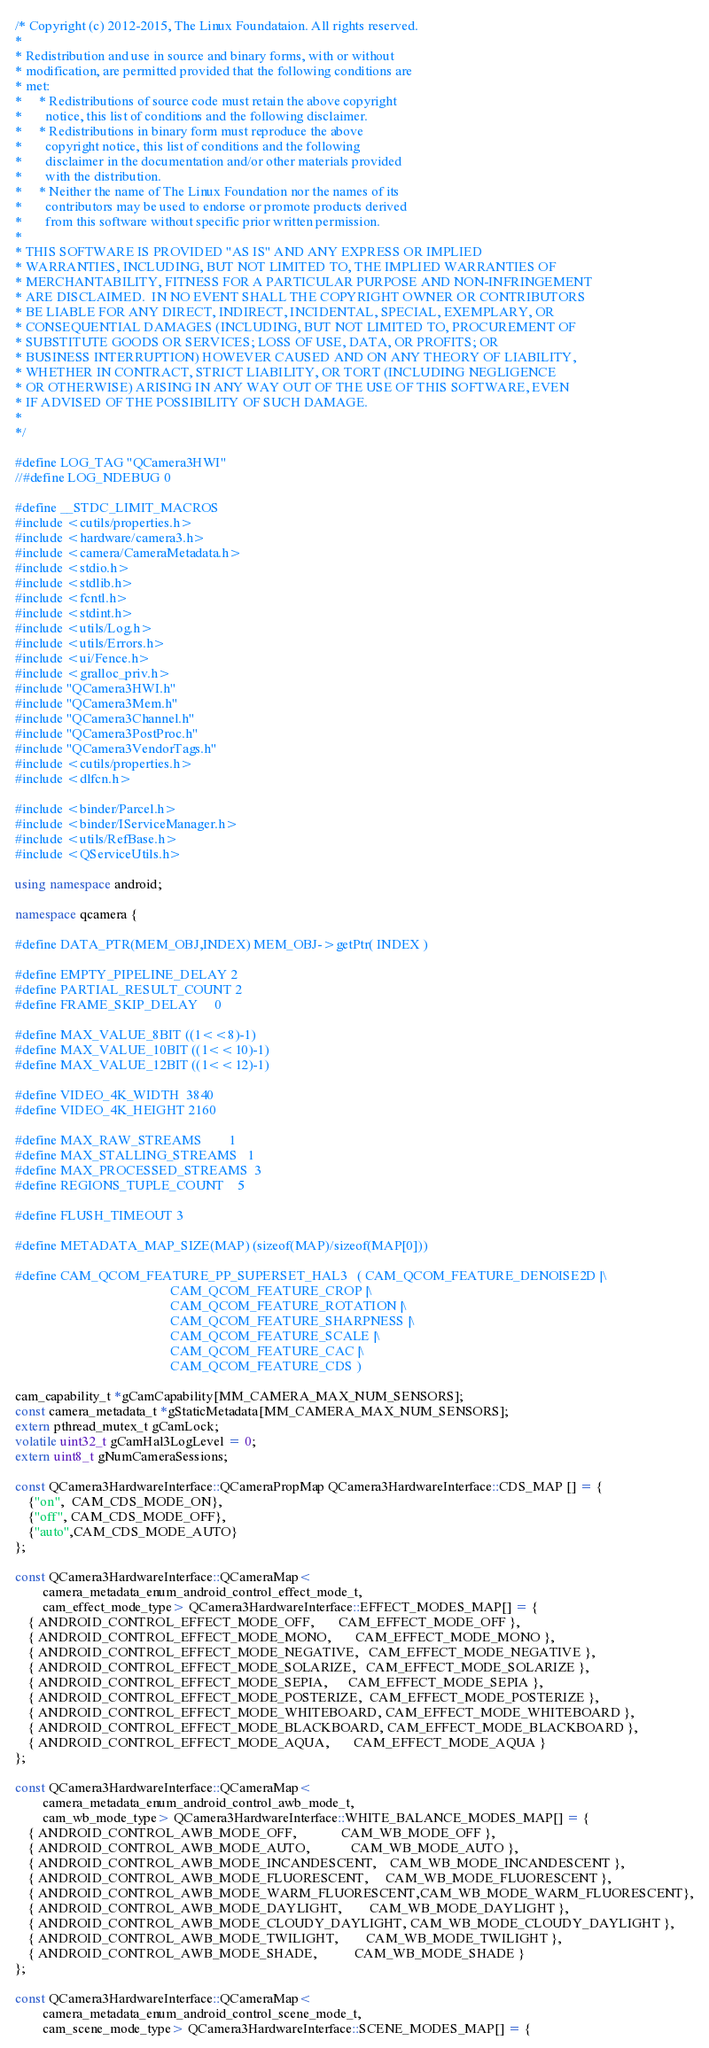Convert code to text. <code><loc_0><loc_0><loc_500><loc_500><_C++_>/* Copyright (c) 2012-2015, The Linux Foundataion. All rights reserved.
*
* Redistribution and use in source and binary forms, with or without
* modification, are permitted provided that the following conditions are
* met:
*     * Redistributions of source code must retain the above copyright
*       notice, this list of conditions and the following disclaimer.
*     * Redistributions in binary form must reproduce the above
*       copyright notice, this list of conditions and the following
*       disclaimer in the documentation and/or other materials provided
*       with the distribution.
*     * Neither the name of The Linux Foundation nor the names of its
*       contributors may be used to endorse or promote products derived
*       from this software without specific prior written permission.
*
* THIS SOFTWARE IS PROVIDED "AS IS" AND ANY EXPRESS OR IMPLIED
* WARRANTIES, INCLUDING, BUT NOT LIMITED TO, THE IMPLIED WARRANTIES OF
* MERCHANTABILITY, FITNESS FOR A PARTICULAR PURPOSE AND NON-INFRINGEMENT
* ARE DISCLAIMED.  IN NO EVENT SHALL THE COPYRIGHT OWNER OR CONTRIBUTORS
* BE LIABLE FOR ANY DIRECT, INDIRECT, INCIDENTAL, SPECIAL, EXEMPLARY, OR
* CONSEQUENTIAL DAMAGES (INCLUDING, BUT NOT LIMITED TO, PROCUREMENT OF
* SUBSTITUTE GOODS OR SERVICES; LOSS OF USE, DATA, OR PROFITS; OR
* BUSINESS INTERRUPTION) HOWEVER CAUSED AND ON ANY THEORY OF LIABILITY,
* WHETHER IN CONTRACT, STRICT LIABILITY, OR TORT (INCLUDING NEGLIGENCE
* OR OTHERWISE) ARISING IN ANY WAY OUT OF THE USE OF THIS SOFTWARE, EVEN
* IF ADVISED OF THE POSSIBILITY OF SUCH DAMAGE.
*
*/

#define LOG_TAG "QCamera3HWI"
//#define LOG_NDEBUG 0

#define __STDC_LIMIT_MACROS
#include <cutils/properties.h>
#include <hardware/camera3.h>
#include <camera/CameraMetadata.h>
#include <stdio.h>
#include <stdlib.h>
#include <fcntl.h>
#include <stdint.h>
#include <utils/Log.h>
#include <utils/Errors.h>
#include <ui/Fence.h>
#include <gralloc_priv.h>
#include "QCamera3HWI.h"
#include "QCamera3Mem.h"
#include "QCamera3Channel.h"
#include "QCamera3PostProc.h"
#include "QCamera3VendorTags.h"
#include <cutils/properties.h>
#include <dlfcn.h>

#include <binder/Parcel.h>
#include <binder/IServiceManager.h>
#include <utils/RefBase.h>
#include <QServiceUtils.h>

using namespace android;

namespace qcamera {

#define DATA_PTR(MEM_OBJ,INDEX) MEM_OBJ->getPtr( INDEX )

#define EMPTY_PIPELINE_DELAY 2
#define PARTIAL_RESULT_COUNT 2
#define FRAME_SKIP_DELAY     0

#define MAX_VALUE_8BIT ((1<<8)-1)
#define MAX_VALUE_10BIT ((1<<10)-1)
#define MAX_VALUE_12BIT ((1<<12)-1)

#define VIDEO_4K_WIDTH  3840
#define VIDEO_4K_HEIGHT 2160

#define MAX_RAW_STREAMS        1
#define MAX_STALLING_STREAMS   1
#define MAX_PROCESSED_STREAMS  3
#define REGIONS_TUPLE_COUNT    5

#define FLUSH_TIMEOUT 3

#define METADATA_MAP_SIZE(MAP) (sizeof(MAP)/sizeof(MAP[0]))

#define CAM_QCOM_FEATURE_PP_SUPERSET_HAL3   ( CAM_QCOM_FEATURE_DENOISE2D |\
                                              CAM_QCOM_FEATURE_CROP |\
                                              CAM_QCOM_FEATURE_ROTATION |\
                                              CAM_QCOM_FEATURE_SHARPNESS |\
                                              CAM_QCOM_FEATURE_SCALE |\
                                              CAM_QCOM_FEATURE_CAC |\
                                              CAM_QCOM_FEATURE_CDS )

cam_capability_t *gCamCapability[MM_CAMERA_MAX_NUM_SENSORS];
const camera_metadata_t *gStaticMetadata[MM_CAMERA_MAX_NUM_SENSORS];
extern pthread_mutex_t gCamLock;
volatile uint32_t gCamHal3LogLevel = 0;
extern uint8_t gNumCameraSessions;

const QCamera3HardwareInterface::QCameraPropMap QCamera3HardwareInterface::CDS_MAP [] = {
    {"on",  CAM_CDS_MODE_ON},
    {"off", CAM_CDS_MODE_OFF},
    {"auto",CAM_CDS_MODE_AUTO}
};

const QCamera3HardwareInterface::QCameraMap<
        camera_metadata_enum_android_control_effect_mode_t,
        cam_effect_mode_type> QCamera3HardwareInterface::EFFECT_MODES_MAP[] = {
    { ANDROID_CONTROL_EFFECT_MODE_OFF,       CAM_EFFECT_MODE_OFF },
    { ANDROID_CONTROL_EFFECT_MODE_MONO,       CAM_EFFECT_MODE_MONO },
    { ANDROID_CONTROL_EFFECT_MODE_NEGATIVE,   CAM_EFFECT_MODE_NEGATIVE },
    { ANDROID_CONTROL_EFFECT_MODE_SOLARIZE,   CAM_EFFECT_MODE_SOLARIZE },
    { ANDROID_CONTROL_EFFECT_MODE_SEPIA,      CAM_EFFECT_MODE_SEPIA },
    { ANDROID_CONTROL_EFFECT_MODE_POSTERIZE,  CAM_EFFECT_MODE_POSTERIZE },
    { ANDROID_CONTROL_EFFECT_MODE_WHITEBOARD, CAM_EFFECT_MODE_WHITEBOARD },
    { ANDROID_CONTROL_EFFECT_MODE_BLACKBOARD, CAM_EFFECT_MODE_BLACKBOARD },
    { ANDROID_CONTROL_EFFECT_MODE_AQUA,       CAM_EFFECT_MODE_AQUA }
};

const QCamera3HardwareInterface::QCameraMap<
        camera_metadata_enum_android_control_awb_mode_t,
        cam_wb_mode_type> QCamera3HardwareInterface::WHITE_BALANCE_MODES_MAP[] = {
    { ANDROID_CONTROL_AWB_MODE_OFF,             CAM_WB_MODE_OFF },
    { ANDROID_CONTROL_AWB_MODE_AUTO,            CAM_WB_MODE_AUTO },
    { ANDROID_CONTROL_AWB_MODE_INCANDESCENT,    CAM_WB_MODE_INCANDESCENT },
    { ANDROID_CONTROL_AWB_MODE_FLUORESCENT,     CAM_WB_MODE_FLUORESCENT },
    { ANDROID_CONTROL_AWB_MODE_WARM_FLUORESCENT,CAM_WB_MODE_WARM_FLUORESCENT},
    { ANDROID_CONTROL_AWB_MODE_DAYLIGHT,        CAM_WB_MODE_DAYLIGHT },
    { ANDROID_CONTROL_AWB_MODE_CLOUDY_DAYLIGHT, CAM_WB_MODE_CLOUDY_DAYLIGHT },
    { ANDROID_CONTROL_AWB_MODE_TWILIGHT,        CAM_WB_MODE_TWILIGHT },
    { ANDROID_CONTROL_AWB_MODE_SHADE,           CAM_WB_MODE_SHADE }
};

const QCamera3HardwareInterface::QCameraMap<
        camera_metadata_enum_android_control_scene_mode_t,
        cam_scene_mode_type> QCamera3HardwareInterface::SCENE_MODES_MAP[] = {</code> 